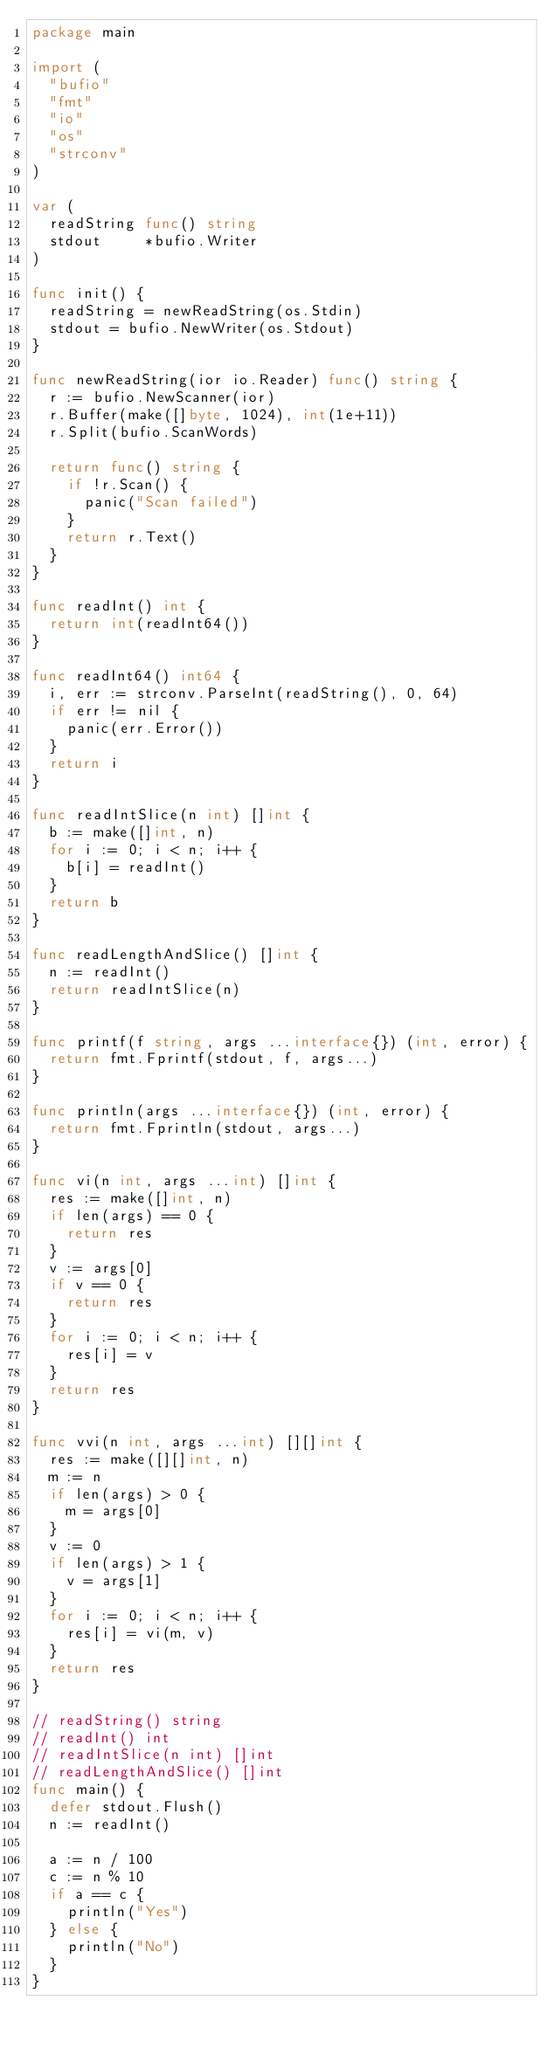Convert code to text. <code><loc_0><loc_0><loc_500><loc_500><_Go_>package main

import (
	"bufio"
	"fmt"
	"io"
	"os"
	"strconv"
)

var (
	readString func() string
	stdout     *bufio.Writer
)

func init() {
	readString = newReadString(os.Stdin)
	stdout = bufio.NewWriter(os.Stdout)
}

func newReadString(ior io.Reader) func() string {
	r := bufio.NewScanner(ior)
	r.Buffer(make([]byte, 1024), int(1e+11))
	r.Split(bufio.ScanWords)

	return func() string {
		if !r.Scan() {
			panic("Scan failed")
		}
		return r.Text()
	}
}

func readInt() int {
	return int(readInt64())
}

func readInt64() int64 {
	i, err := strconv.ParseInt(readString(), 0, 64)
	if err != nil {
		panic(err.Error())
	}
	return i
}

func readIntSlice(n int) []int {
	b := make([]int, n)
	for i := 0; i < n; i++ {
		b[i] = readInt()
	}
	return b
}

func readLengthAndSlice() []int {
	n := readInt()
	return readIntSlice(n)
}

func printf(f string, args ...interface{}) (int, error) {
	return fmt.Fprintf(stdout, f, args...)
}

func println(args ...interface{}) (int, error) {
	return fmt.Fprintln(stdout, args...)
}

func vi(n int, args ...int) []int {
	res := make([]int, n)
	if len(args) == 0 {
		return res
	}
	v := args[0]
	if v == 0 {
		return res
	}
	for i := 0; i < n; i++ {
		res[i] = v
	}
	return res
}

func vvi(n int, args ...int) [][]int {
	res := make([][]int, n)
	m := n
	if len(args) > 0 {
		m = args[0]
	}
	v := 0
	if len(args) > 1 {
		v = args[1]
	}
	for i := 0; i < n; i++ {
		res[i] = vi(m, v)
	}
	return res
}

// readString() string
// readInt() int
// readIntSlice(n int) []int
// readLengthAndSlice() []int
func main() {
	defer stdout.Flush()
	n := readInt()

	a := n / 100
	c := n % 10
	if a == c {
		println("Yes")
	} else {
		println("No")
	}
}
</code> 